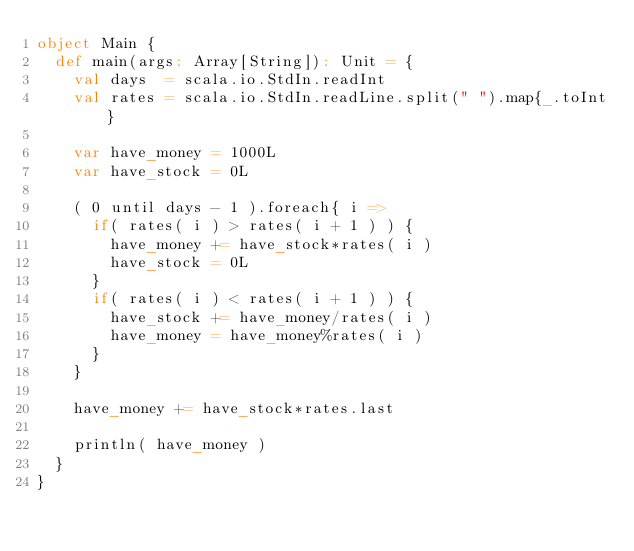Convert code to text. <code><loc_0><loc_0><loc_500><loc_500><_Scala_>object Main {
  def main(args: Array[String]): Unit = {
    val days  = scala.io.StdIn.readInt
    val rates = scala.io.StdIn.readLine.split(" ").map{_.toInt}

    var have_money = 1000L
    var have_stock = 0L

    ( 0 until days - 1 ).foreach{ i =>
      if( rates( i ) > rates( i + 1 ) ) {
        have_money += have_stock*rates( i )
        have_stock = 0L
      }
      if( rates( i ) < rates( i + 1 ) ) {
        have_stock += have_money/rates( i )
        have_money = have_money%rates( i )
      }
    }

    have_money += have_stock*rates.last

    println( have_money )
  }
}</code> 